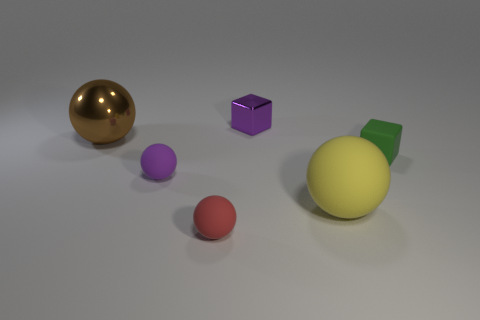There is a big ball behind the tiny green matte thing; how many tiny red rubber balls are in front of it?
Ensure brevity in your answer.  1. There is a metal thing behind the big brown metallic sphere; are there any brown metallic objects to the right of it?
Provide a succinct answer. No. Are there any big metal spheres in front of the big yellow ball?
Make the answer very short. No. Do the tiny matte thing that is right of the yellow object and the tiny red thing have the same shape?
Give a very brief answer. No. How many other yellow rubber things have the same shape as the large yellow rubber object?
Ensure brevity in your answer.  0. Are there any blue balls made of the same material as the big yellow thing?
Give a very brief answer. No. There is a small object that is behind the large thing on the left side of the yellow rubber sphere; what is it made of?
Make the answer very short. Metal. What is the size of the cube on the left side of the large yellow sphere?
Provide a short and direct response. Small. Does the big shiny thing have the same color as the small block that is in front of the brown metal sphere?
Provide a succinct answer. No. Is there a tiny metal block of the same color as the big rubber object?
Give a very brief answer. No. 